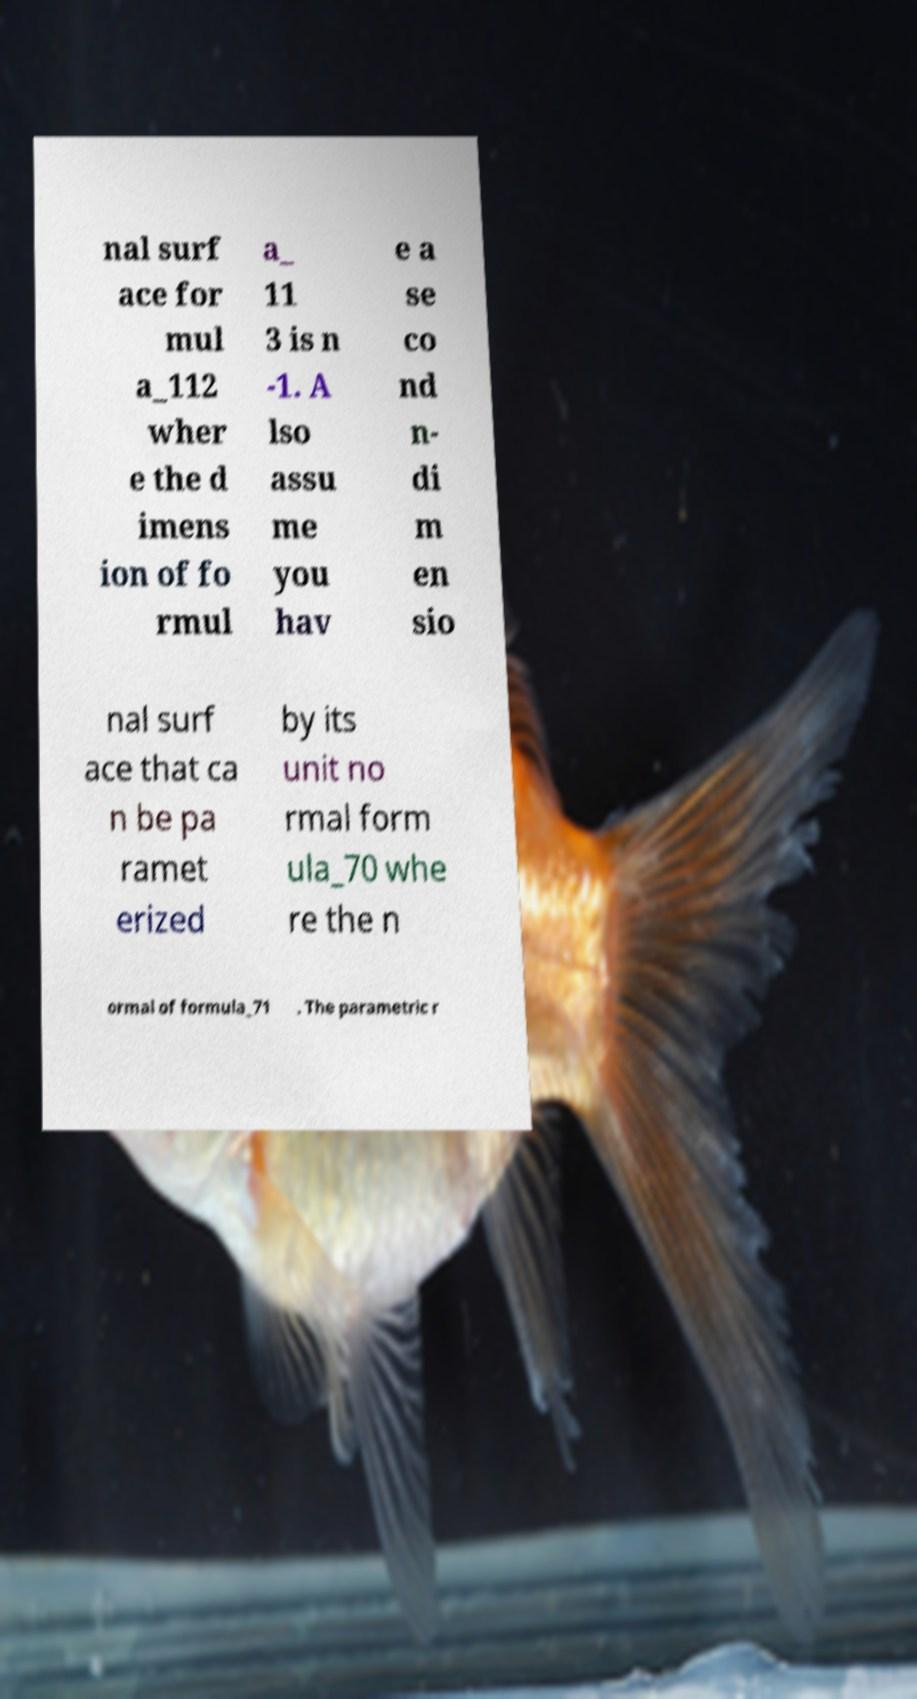Can you accurately transcribe the text from the provided image for me? nal surf ace for mul a_112 wher e the d imens ion of fo rmul a_ 11 3 is n -1. A lso assu me you hav e a se co nd n- di m en sio nal surf ace that ca n be pa ramet erized by its unit no rmal form ula_70 whe re the n ormal of formula_71 . The parametric r 